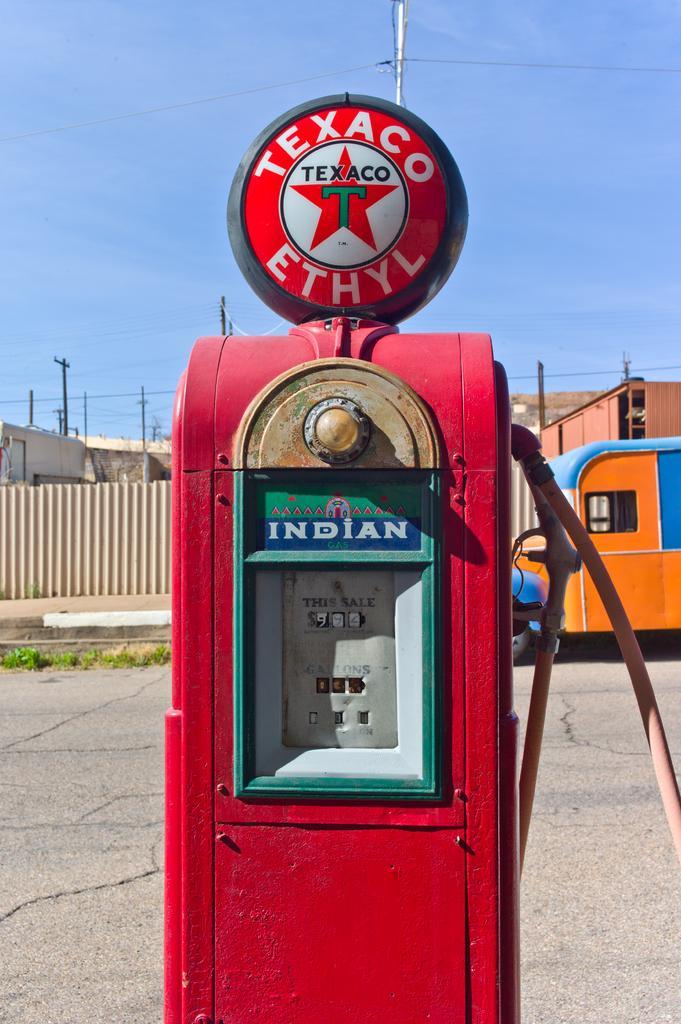Could you give a brief overview of what you see in this image? In this image we can see sky, electric poles, electric cables, motor vehicles on the road, grass and a machine. 